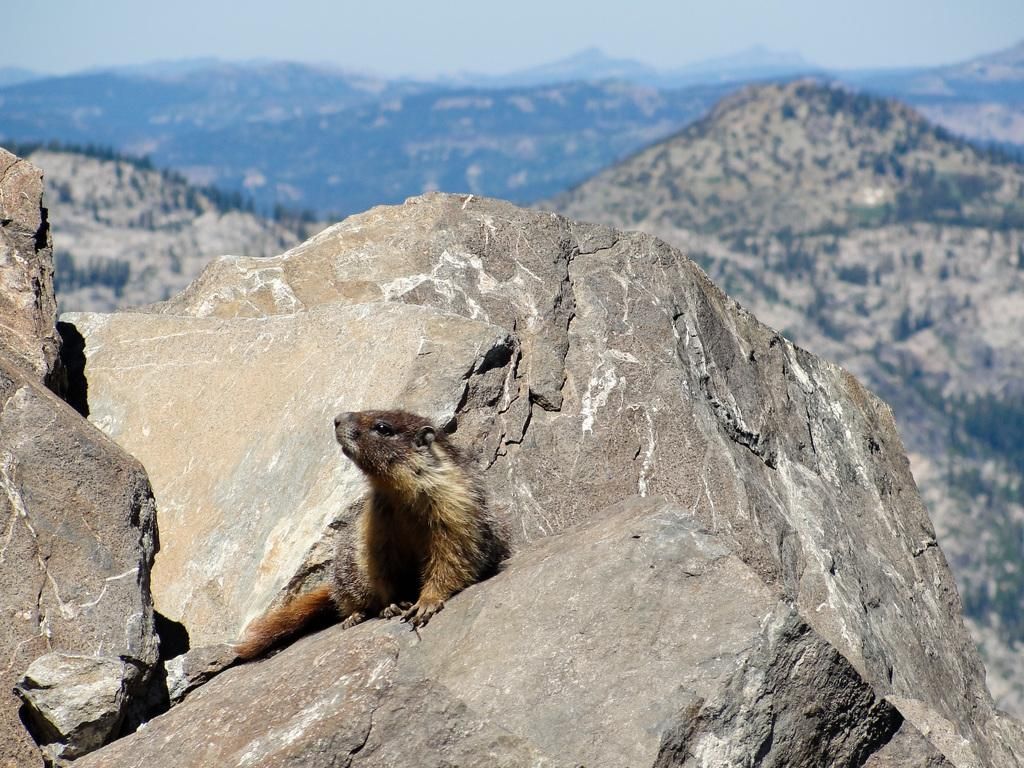What animal can be seen in the image? There is a beaver in the image. Where is the beaver located? The beaver is sitting on a stone. What can be seen in the background of the image? There are mountains in the background of the image. What type of vegetation is present on the mountains? Trees are present on the mountains in the background. What time does the clock show in the image? There is no clock present in the image. How many snails can be seen crawling on the beaver in the image? There are no snails present in the image; it features a beaver sitting on a stone. 